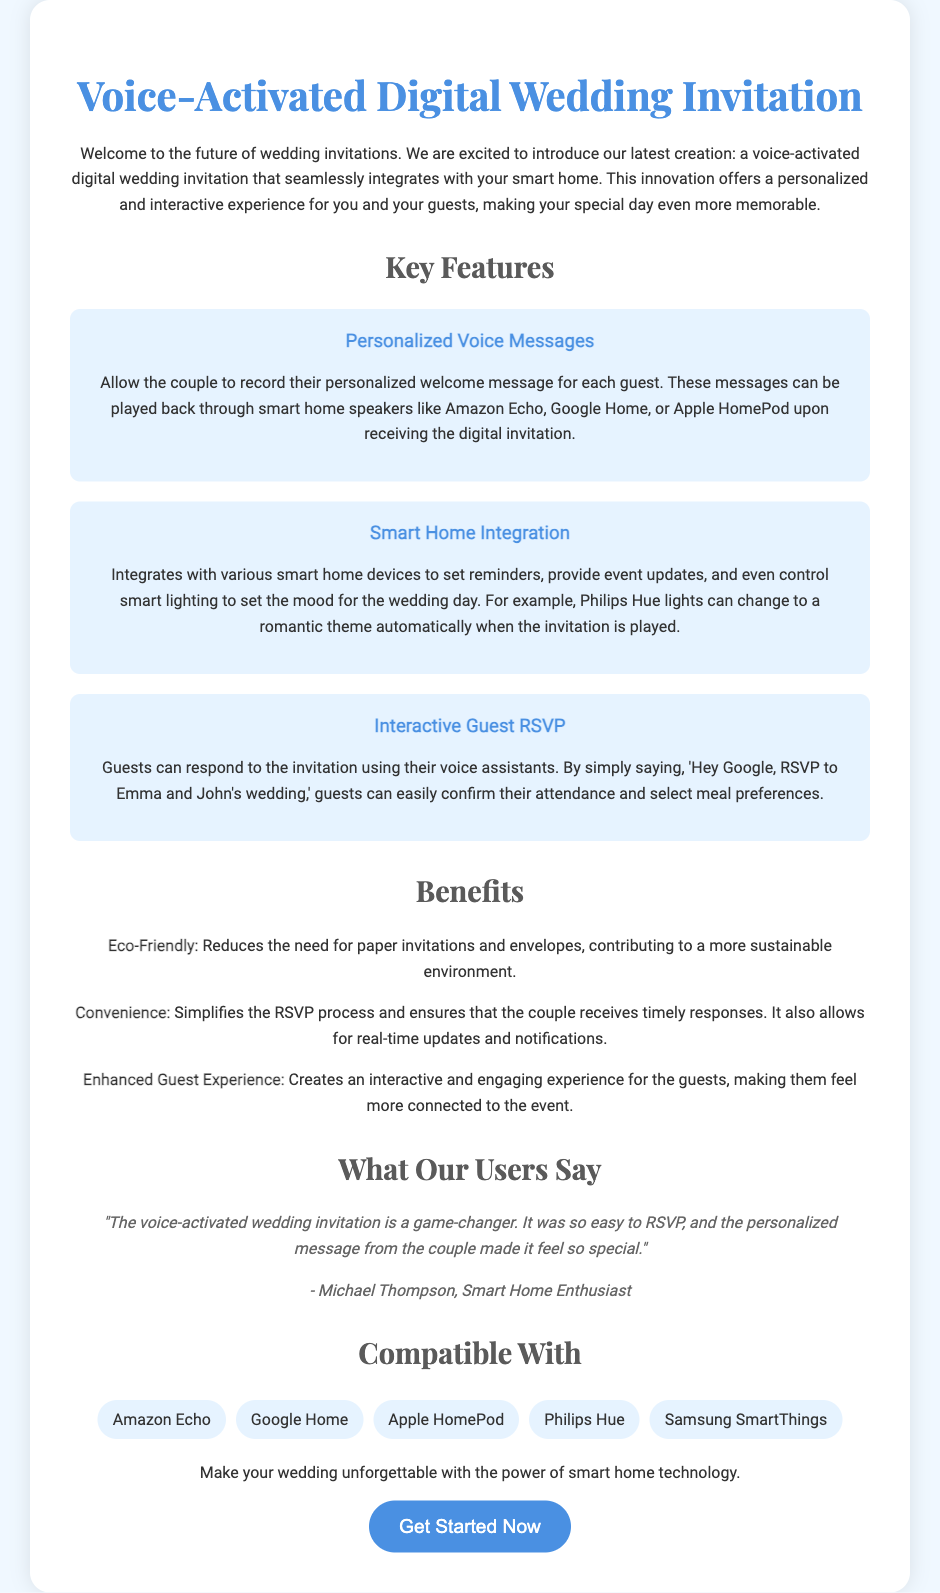What is the title of the invitation? The title of the invitation is prominently displayed at the top of the document.
Answer: Voice-Activated Digital Wedding Invitation Who can record personalized messages? The document specifies that the couple is able to record their messages.
Answer: The couple What is one of the key features that enhances the guest experience? The document lists multiple features; one of them enhances the guest experience through interaction.
Answer: Interactive Guest RSVP Which smart home device changes lighting for the wedding day? The document mentions a specific smart home device responsible for lighting changes for the wedding.
Answer: Philips Hue How do guests confirm their attendance? The explanation in the document describes how guests can respond using their voice assistants.
Answer: By voice command What is one benefit of using the digital wedding invitation? The document lists several benefits, one of which relates to sustainability.
Answer: Eco-Friendly Who provided a testimonial for the invitation? The document includes a specific person's name that provides positive feedback.
Answer: Michael Thompson What color is the button labeled "Get Started Now"? The document describes the button's appearance, including its color.
Answer: Blue 